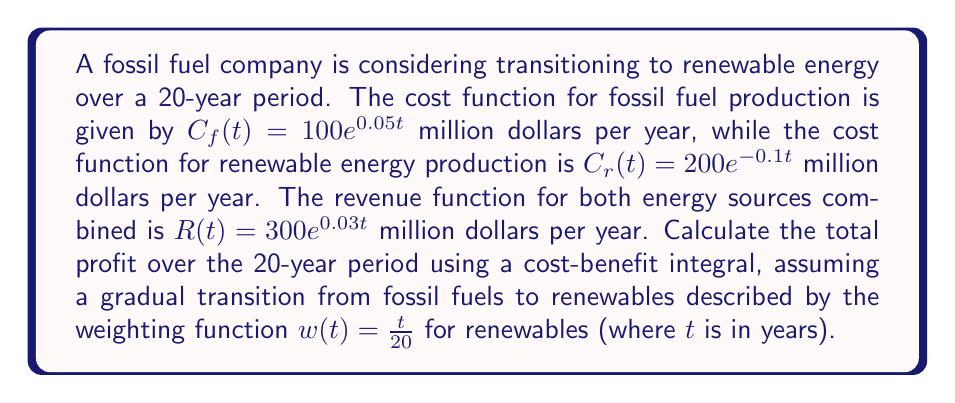Solve this math problem. To solve this problem, we need to follow these steps:

1) The profit function P(t) is the difference between revenue and weighted costs:

   $P(t) = R(t) - [(1-w(t))C_f(t) + w(t)C_r(t)]$

2) Substitute the given functions:

   $P(t) = 300e^{0.03t} - [(1-\frac{t}{20})(100e^{0.05t}) + \frac{t}{20}(200e^{-0.1t})]$

3) The total profit over 20 years is the integral of P(t) from 0 to 20:

   $\text{Total Profit} = \int_0^{20} P(t) dt$

4) Expand the integral:

   $\int_0^{20} [300e^{0.03t} - (100e^{0.05t} - 5te^{0.05t} + 10te^{-0.1t})] dt$

5) Integrate each term:

   $[10000e^{0.03t}]_0^{20} - [2000e^{0.05t}]_0^{20} + [100te^{0.05t} - 5000e^{0.05t}]_0^{20} - [100te^{-0.1t} + 1000e^{-0.1t}]_0^{20}$

6) Evaluate the integral:

   $(10000e^{0.6} - 10000) - (2000e^1 - 2000) + (2000e^1 - 0 - 5000e^1 + 5000) - (2000e^{-2} + 1000e^{-2} - 0 - 1000)$

7) Simplify:

   $10000(e^{0.6} - 1) - 2000(e^1 - 1) + 2000e^1 - 5000e^1 + 5000 - 3000e^{-2} + 1000$

8) Calculate the final value (rounded to nearest million):

   $\approx 3,359$ million dollars
Answer: $3,359$ million dollars 